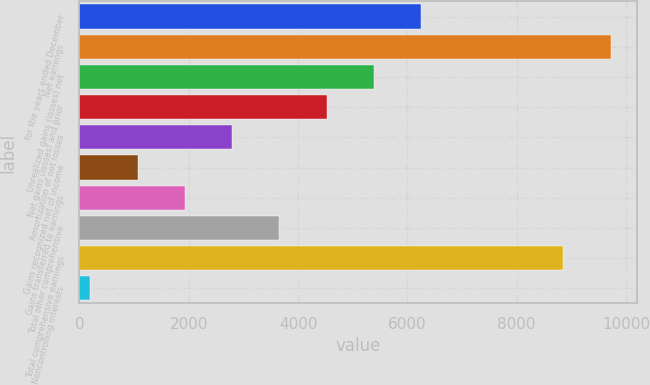<chart> <loc_0><loc_0><loc_500><loc_500><bar_chart><fcel>for the years ended December<fcel>Net earnings<fcel>Unrealized gains (losses) net<fcel>Net gains (losses) and prior<fcel>Amortization of net losses<fcel>Gains recognized net of income<fcel>Gains transferred to earnings<fcel>Total other comprehensive<fcel>Total comprehensive earnings<fcel>Noncontrolling interests<nl><fcel>6254.1<fcel>9720.6<fcel>5388.8<fcel>4523.5<fcel>2792.9<fcel>1062.3<fcel>1927.6<fcel>3658.2<fcel>8855.3<fcel>197<nl></chart> 